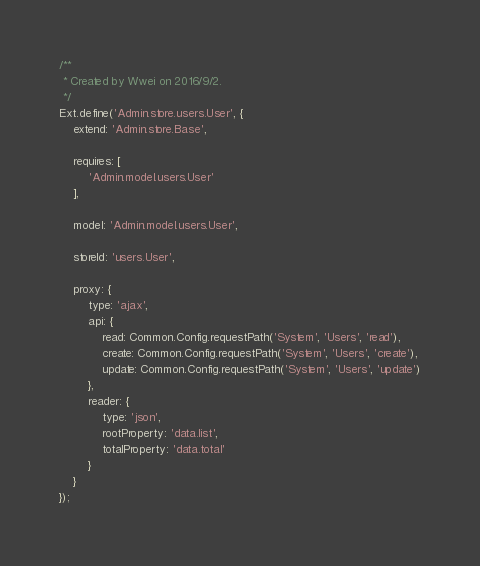Convert code to text. <code><loc_0><loc_0><loc_500><loc_500><_JavaScript_>/**
 * Created by Wwei on 2016/9/2.
 */
Ext.define('Admin.store.users.User', {
    extend: 'Admin.store.Base',

    requires: [
        'Admin.model.users.User'
    ],

    model: 'Admin.model.users.User',

    storeId: 'users.User',

    proxy: {
        type: 'ajax',
        api: {
            read: Common.Config.requestPath('System', 'Users', 'read'),
            create: Common.Config.requestPath('System', 'Users', 'create'),
            update: Common.Config.requestPath('System', 'Users', 'update')
        },
        reader: {
            type: 'json',
            rootProperty: 'data.list',
            totalProperty: 'data.total'
        }
    }
});</code> 